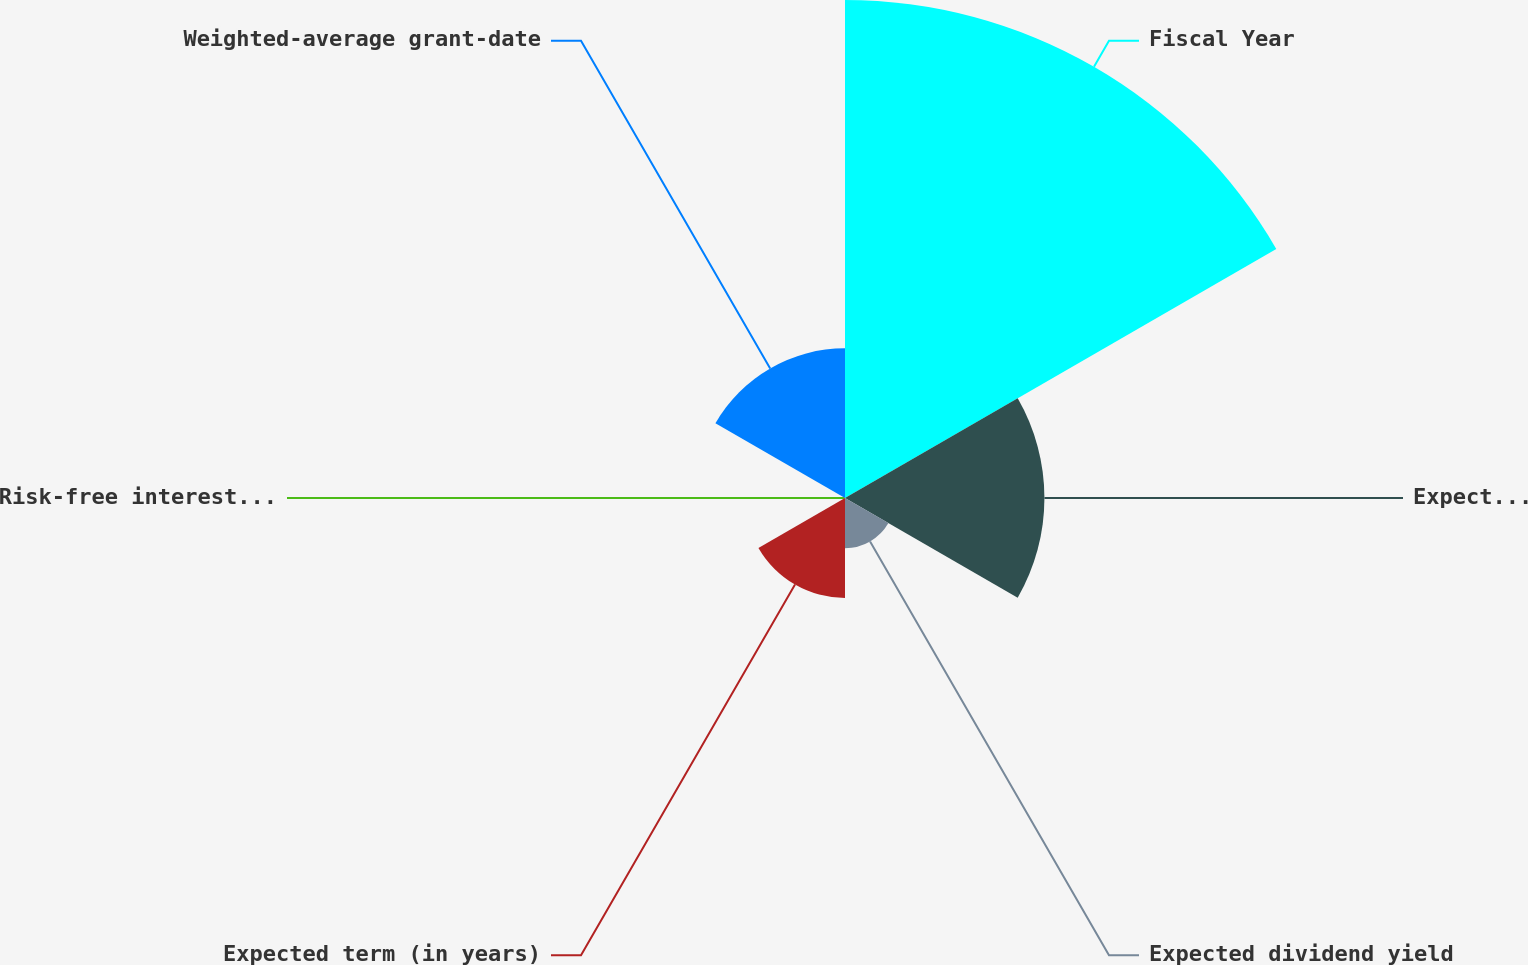Convert chart to OTSL. <chart><loc_0><loc_0><loc_500><loc_500><pie_chart><fcel>Fiscal Year<fcel>Expected volatility<fcel>Expected dividend yield<fcel>Expected term (in years)<fcel>Risk-free interest rate<fcel>Weighted-average grant-date<nl><fcel>49.92%<fcel>19.99%<fcel>5.03%<fcel>10.02%<fcel>0.04%<fcel>15.0%<nl></chart> 